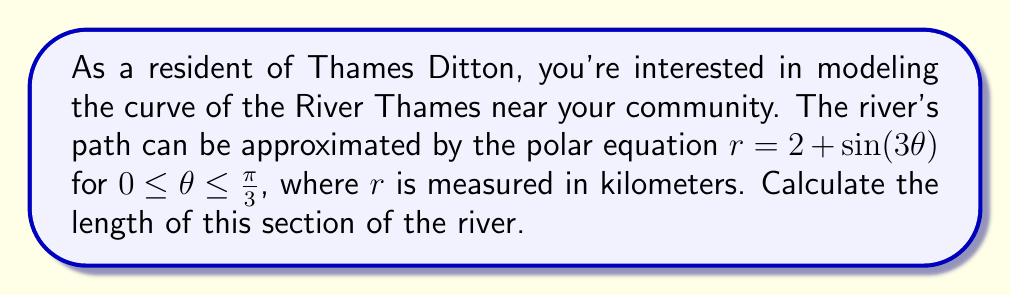Give your solution to this math problem. To find the length of a curve in polar coordinates, we use the arc length formula:

$$L = \int_a^b \sqrt{r^2 + \left(\frac{dr}{d\theta}\right)^2} d\theta$$

Where $r = 2 + \sin(3\theta)$ and $\frac{dr}{d\theta} = 3\cos(3\theta)$.

Steps:
1) First, calculate $r^2$:
   $r^2 = (2 + \sin(3\theta))^2 = 4 + 4\sin(3\theta) + \sin^2(3\theta)$

2) Calculate $\left(\frac{dr}{d\theta}\right)^2$:
   $\left(\frac{dr}{d\theta}\right)^2 = (3\cos(3\theta))^2 = 9\cos^2(3\theta)$

3) Add these together:
   $r^2 + \left(\frac{dr}{d\theta}\right)^2 = 4 + 4\sin(3\theta) + \sin^2(3\theta) + 9\cos^2(3\theta)$
   
   $= 4 + 4\sin(3\theta) + 9 - 9\sin^2(3\theta) + 9\cos^2(3\theta)$ (using $\sin^2 + \cos^2 = 1$)
   
   $= 13 + 4\sin(3\theta)$

4) Take the square root:
   $\sqrt{r^2 + \left(\frac{dr}{d\theta}\right)^2} = \sqrt{13 + 4\sin(3\theta)}$

5) Set up the integral:
   $$L = \int_0^{\frac{\pi}{3}} \sqrt{13 + 4\sin(3\theta)} d\theta$$

6) This integral doesn't have an elementary antiderivative, so we need to use numerical methods to approximate it. Using a computer algebra system or numerical integration tool, we can evaluate this integral.

The result of this numerical integration is approximately 3.8416 kilometers.
Answer: The length of the River Thames' curve near Thames Ditton, as modeled by the given polar equation, is approximately 3.84 km. 